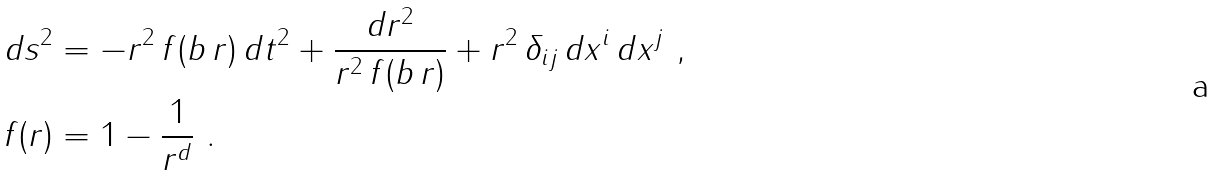Convert formula to latex. <formula><loc_0><loc_0><loc_500><loc_500>d s ^ { 2 } & = - r ^ { 2 } \, f ( b \, r ) \, d t ^ { 2 } + \frac { d r ^ { 2 } } { r ^ { 2 } \, f ( b \, r ) } + r ^ { 2 } \, \delta _ { i j } \, d x ^ { i } \, d x ^ { j } \ , \\ f ( r ) & = 1 - \frac { 1 } { r ^ { d } } \ .</formula> 